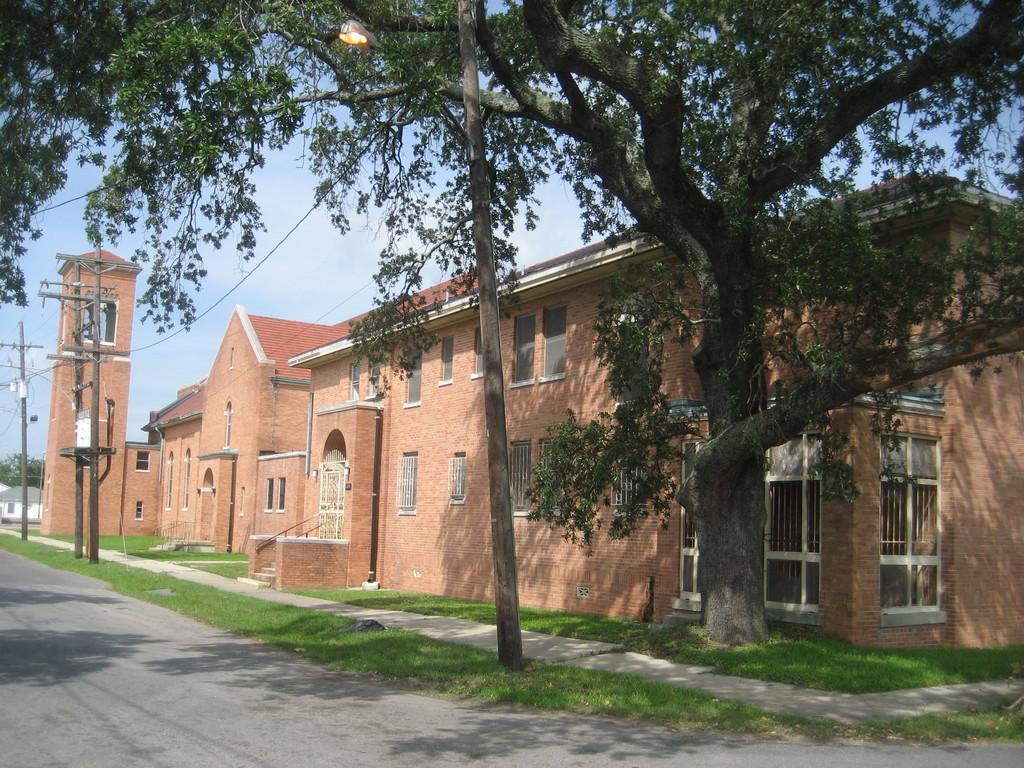Describe this image in one or two sentences. In this image we can see there is a building beside the road also there are some electrical poles and trees. 